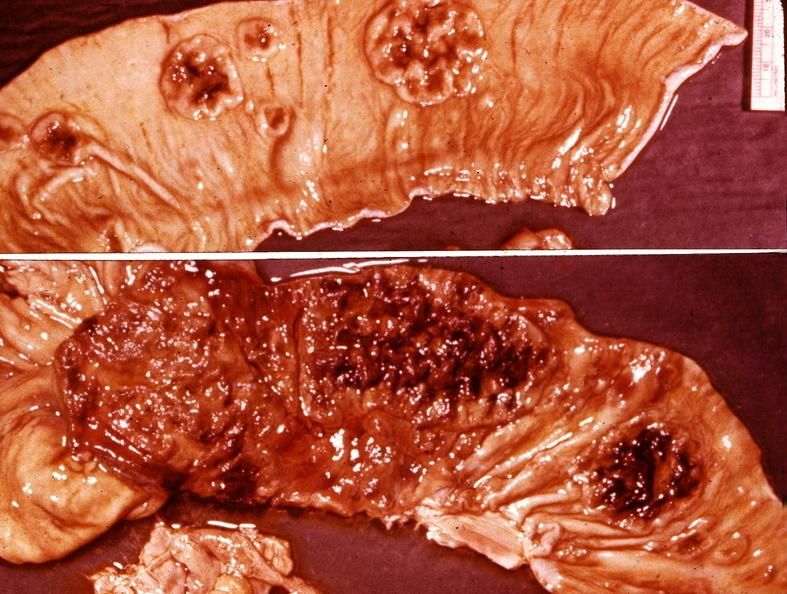what is present?
Answer the question using a single word or phrase. Gastrointestinal 